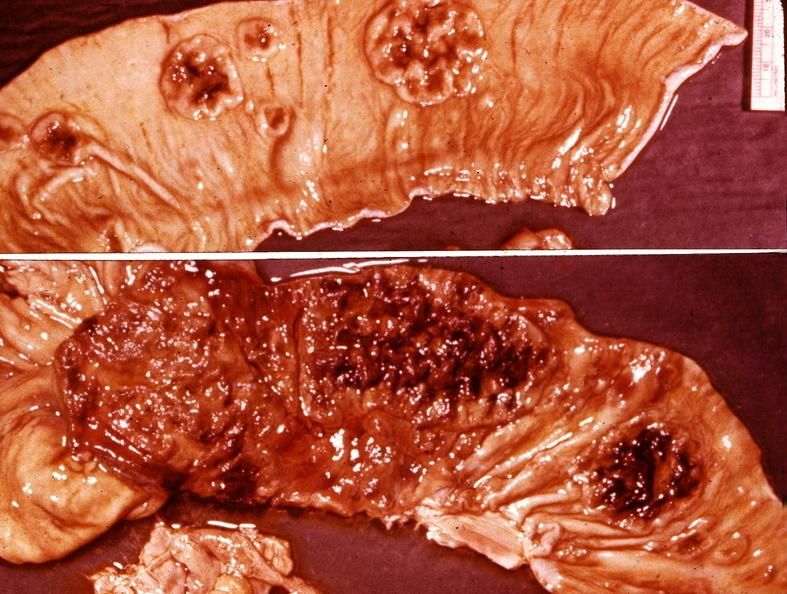what is present?
Answer the question using a single word or phrase. Gastrointestinal 